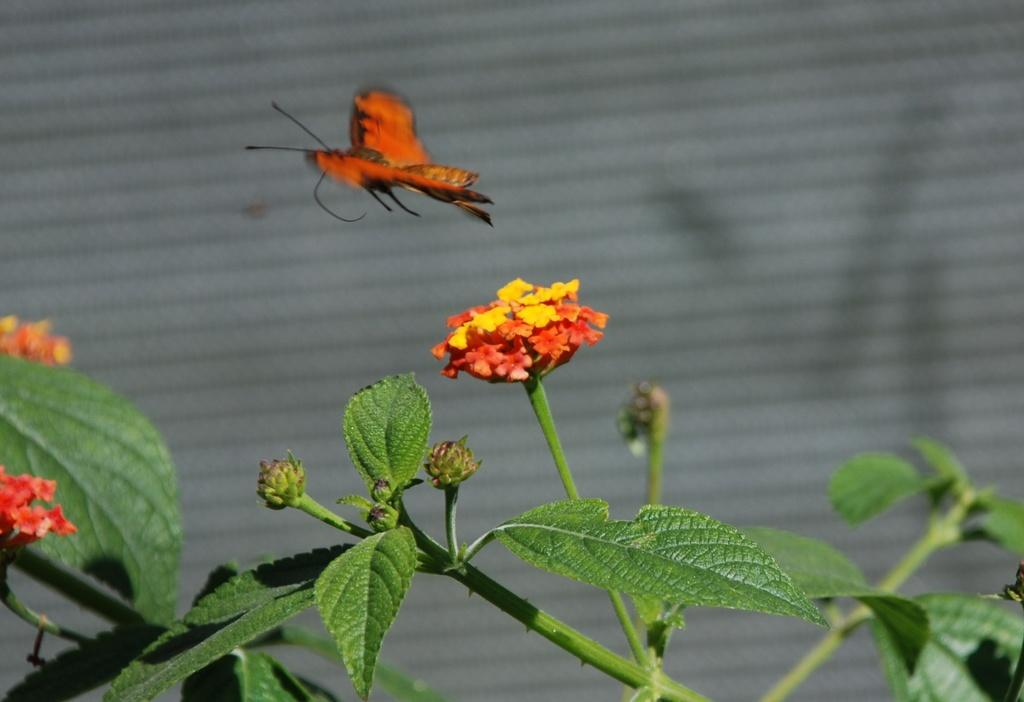What type of plants are visible in the image? There are plants with flowers in the image. What other living creature can be seen in the image? There is a butterfly in the image. What color is the background of the image? The background of the image is white. What type of ring is the butterfly wearing in the image? There is no ring visible on the butterfly in the image. In the image, where is the middle of the butterfly located? The concept of a "middle" of a butterfly is not applicable, as butterflies are not typically described in terms of a middle point. 